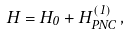<formula> <loc_0><loc_0><loc_500><loc_500>H = H _ { 0 } + H ^ { ( 1 ) } _ { P N C } \, ,</formula> 